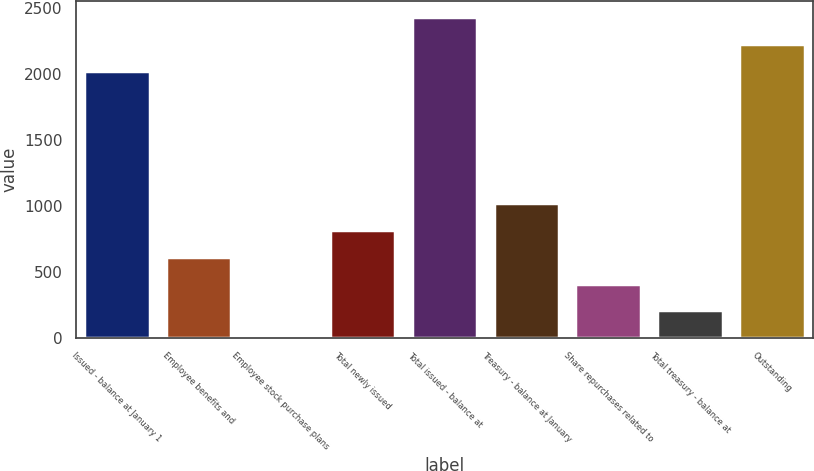<chart> <loc_0><loc_0><loc_500><loc_500><bar_chart><fcel>Issued - balance at January 1<fcel>Employee benefits and<fcel>Employee stock purchase plans<fcel>Total newly issued<fcel>Total issued - balance at<fcel>Treasury - balance at January<fcel>Share repurchases related to<fcel>Total treasury - balance at<fcel>Outstanding<nl><fcel>2023.6<fcel>613.81<fcel>0.7<fcel>818.18<fcel>2432.34<fcel>1022.55<fcel>409.44<fcel>205.07<fcel>2227.97<nl></chart> 